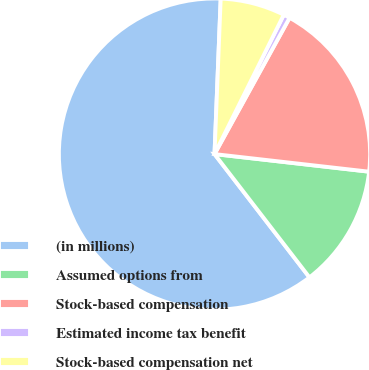<chart> <loc_0><loc_0><loc_500><loc_500><pie_chart><fcel>(in millions)<fcel>Assumed options from<fcel>Stock-based compensation<fcel>Estimated income tax benefit<fcel>Stock-based compensation net<nl><fcel>61.08%<fcel>12.75%<fcel>18.79%<fcel>0.67%<fcel>6.71%<nl></chart> 